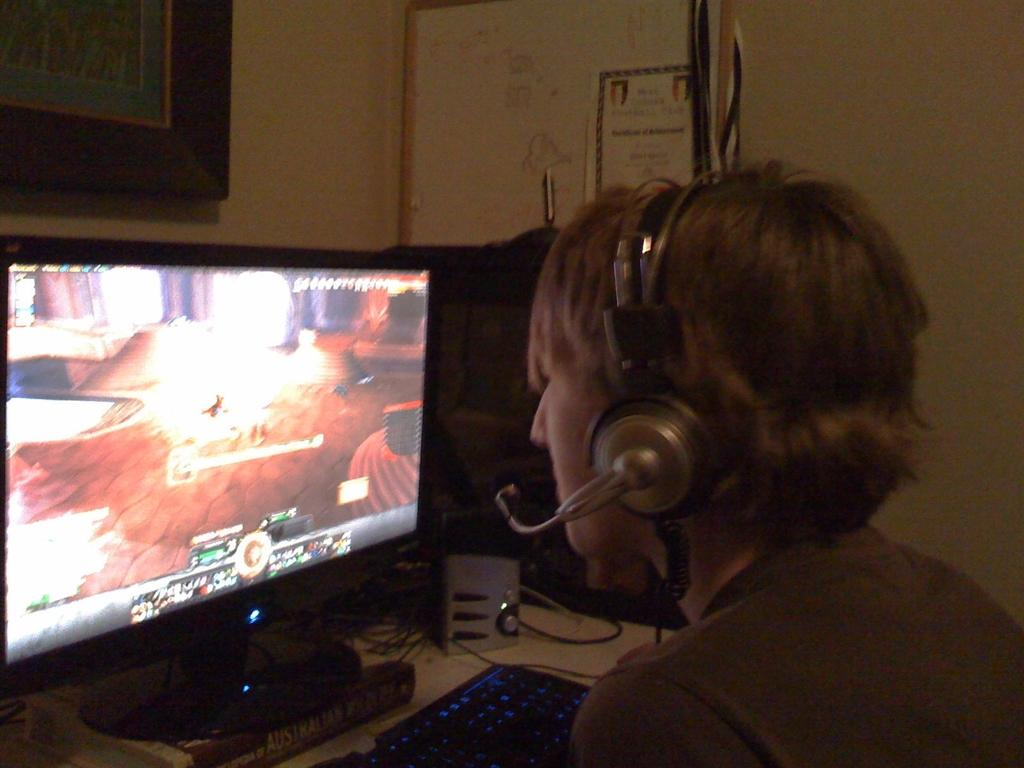What is the main subject of the image? The main subject of the image is a guy. What is the guy wearing in the image? The guy is wearing headphones in the image. What activity is the guy engaged in? The guy is playing a video game on a monitor in the image. What type of bulb is used to light up the room in the image? There is no information about the lighting in the image, so we cannot determine the type of bulb used. What ingredients are used to make the stew in the image? There is no stew present in the image. 